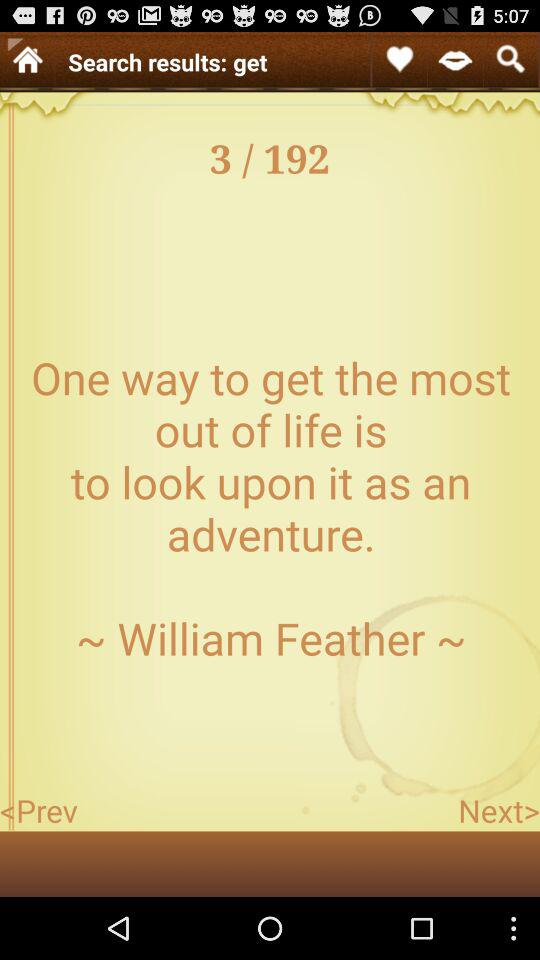Who is William Feather?
When the provided information is insufficient, respond with <no answer>. <no answer> 